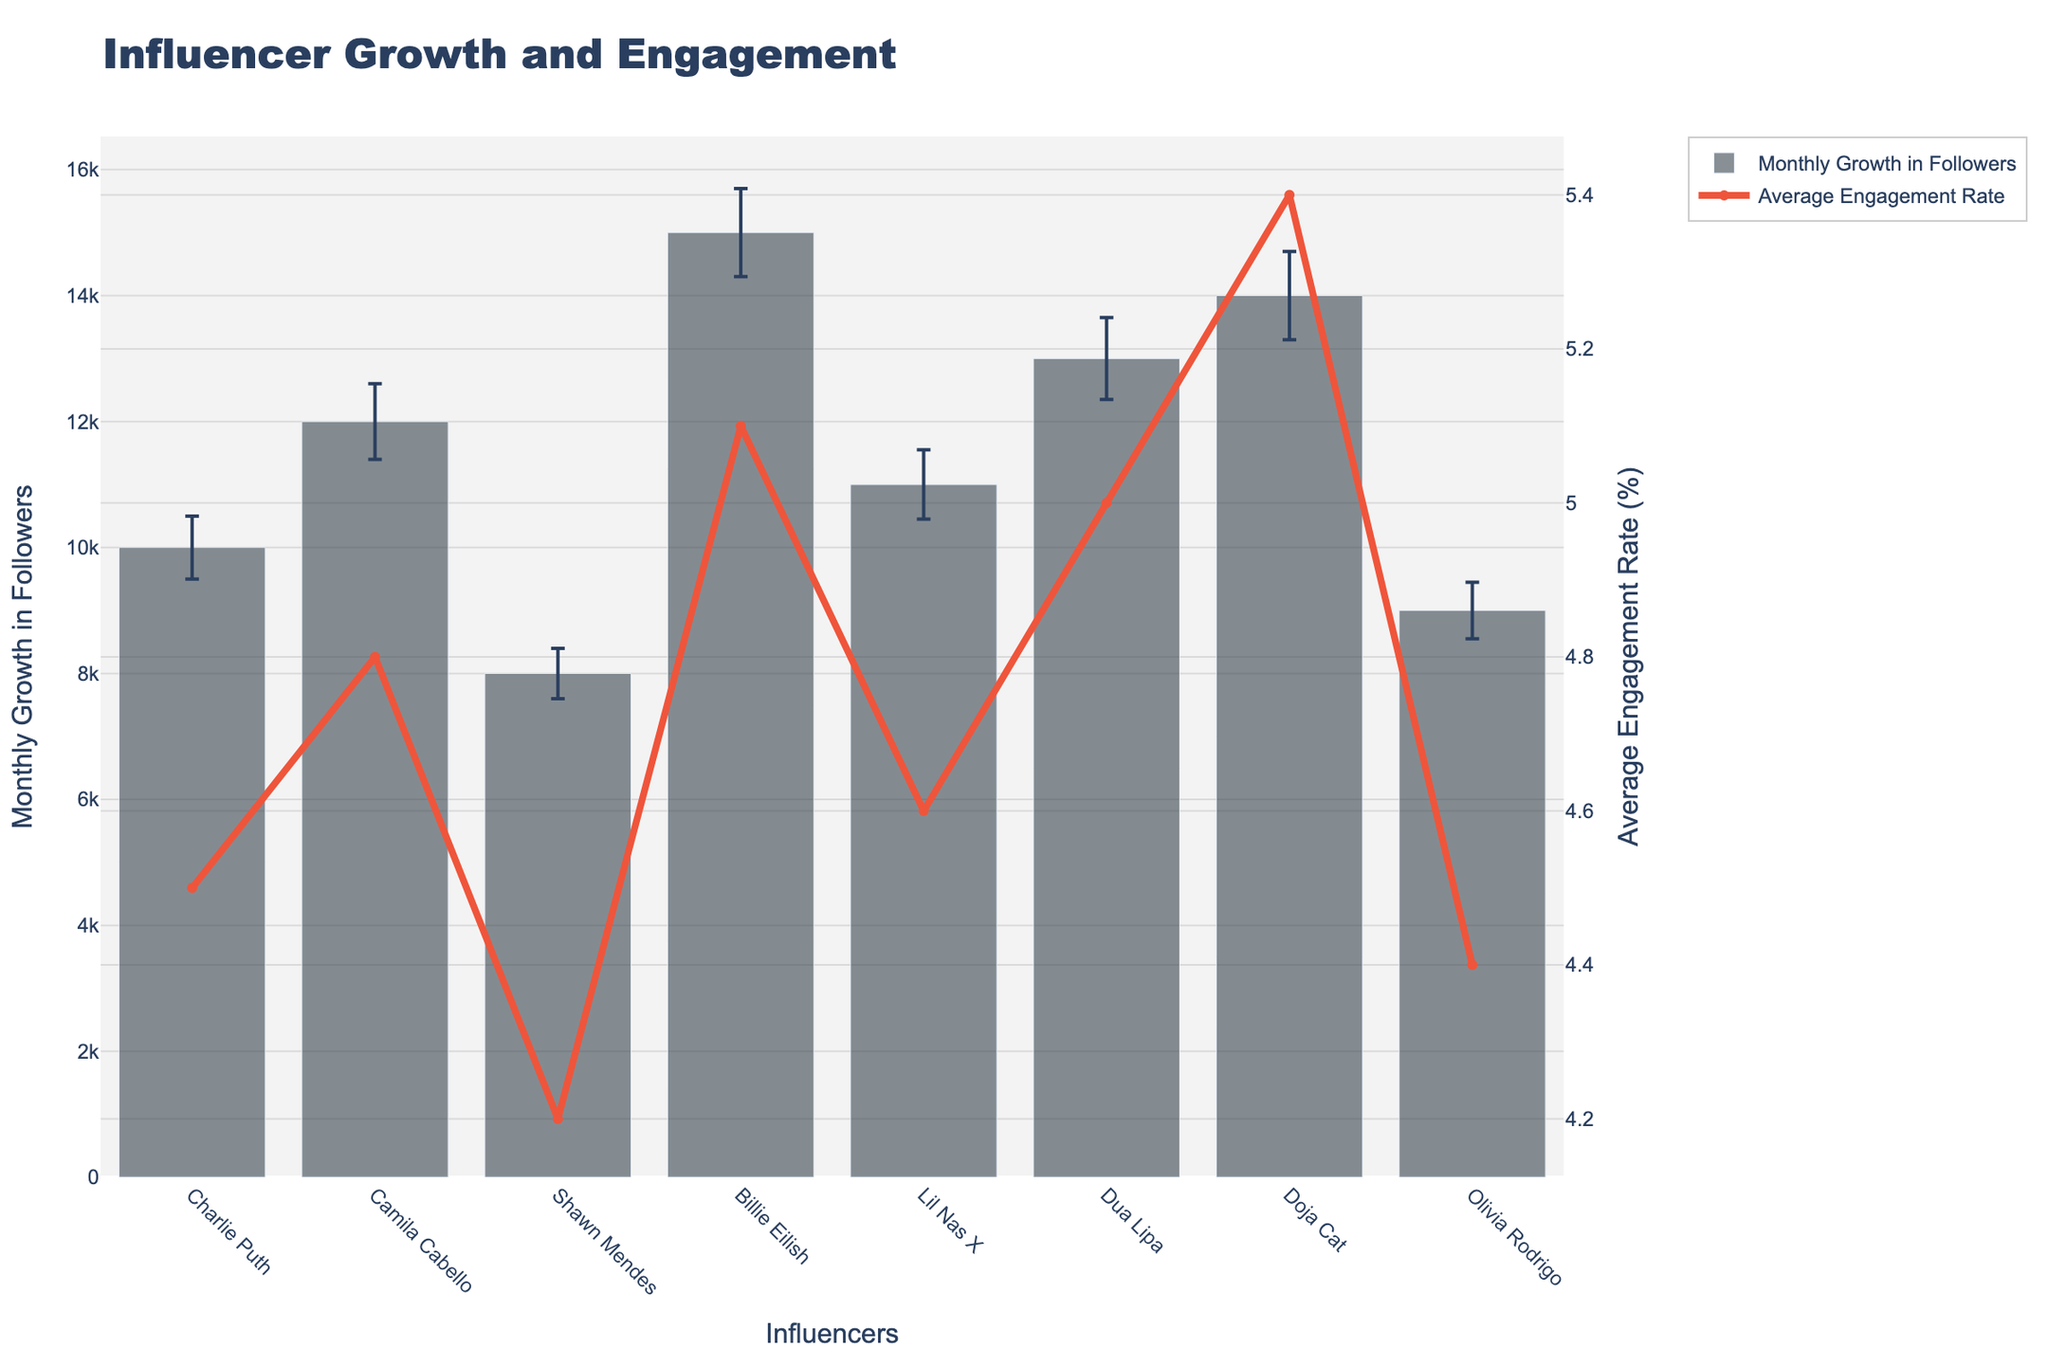What is the title of the chart? The title of the chart is prominently displayed at the top of the figure. It reads "Influencer Growth and Engagement".
Answer: Influencer Growth and Engagement Which influencer has the highest Monthly Growth in Followers? Billie Eilish has the highest Monthly Growth in Followers as her bar reaches the highest point on the y-axis, indicating a value of 15000.
Answer: Billie Eilish What is the Average Engagement Rate for Dua Lipa? The line representing Average Engagement Rate intersects Dua Lipa's bar at the value of 5.0 on the secondary y-axis.
Answer: 5.0 Which influencer has the smallest error bar for Monthly Growth in Followers? Shawn Mendes has the smallest error bar for Monthly Growth in Followers as indicated by the shortest error bar atop his bar on the chart.
Answer: Shawn Mendes How do the Monthly Growth in Followers of Olivia Rodrigo and Shawn Mendes compare? Olivia Rodrigo has a Monthly Growth in Followers of 9000, and Shawn Mendes has 8000. Therefore, Olivia Rodrigo has a higher Monthly Growth in Followers than Shawn Mendes.
Answer: Olivia Rodrigo has higher growth What is the sum of Monthly Growth in Followers for Charlie Puth and Lil Nas X? Adding the Monthly Growth in Followers for Charlie Puth (10000) and Lil Nas X (11000) gives 10000 + 11000 = 21000.
Answer: 21000 Which influencers have an Average Engagement Rate greater than 5%? According to the chart, Doja Cat (5.4%), Billie Eilish (5.1%), and Dua Lipa (5.0%) have Average Engagement Rates greater than 5%.
Answer: Doja Cat, Billie Eilish, and Dua Lipa What is the difference between Camila Cabello's and Doja Cat's Monthly Growth in Followers? Camila Cabello's Monthly Growth in Followers is 12000, and Doja Cat's is 14000. The difference is 14000 - 12000 = 2000.
Answer: 2000 How many influencers have an error bar equal to or greater than 600? By examining the error bars for each influencer, Billie Eilish (700), Camila Cabello (600), Dua Lipa (650), and Doja Cat (700) have error bars equal to or greater than 600.
Answer: 4 